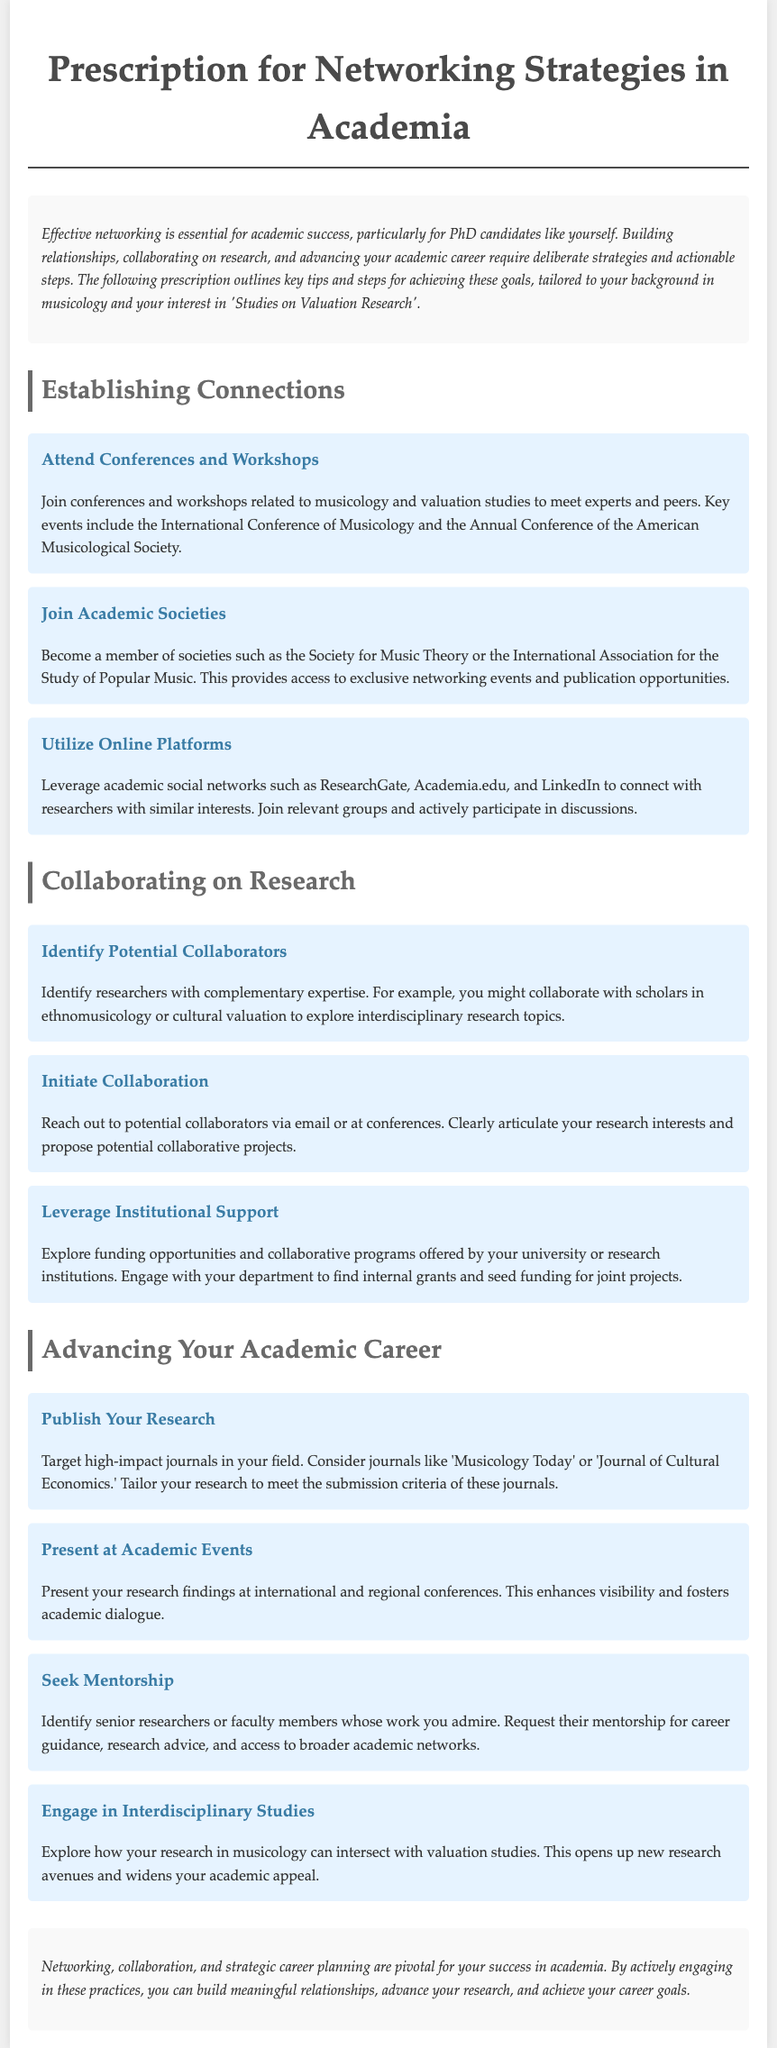What is the title of the document? The title of the document is "Prescription for Networking Strategies in Academia."
Answer: Prescription for Networking Strategies in Academia Who is the intended audience for this prescription? The intended audience for this prescription is PhD candidates, particularly in musicology.
Answer: PhD candidates What is the first tip under “Establishing Connections”? The first tip under "Establishing Connections" is "Attend Conferences and Workshops."
Answer: Attend Conferences and Workshops Which academic society is recommended for membership? The document recommends the "Society for Music Theory" for membership.
Answer: Society for Music Theory What action should you take to initiate collaboration? To initiate collaboration, you should reach out to potential collaborators via email or at conferences.
Answer: Reach out to potential collaborators What is suggested as a way to advance your academic career? The document suggests publishing your research as a way to advance your academic career.
Answer: Publish Your Research Which journals are mentioned for targeting high-impact publications? The mentioned journals for targeting high-impact publications are "Musicology Today" and "Journal of Cultural Economics."
Answer: Musicology Today and Journal of Cultural Economics What is emphasized as crucial for academic success? Effective networking is emphasized as crucial for academic success.
Answer: Effective networking What kind of studies should you engage in to widen your academic appeal? You should engage in interdisciplinary studies to widen your academic appeal.
Answer: Interdisciplinary studies 